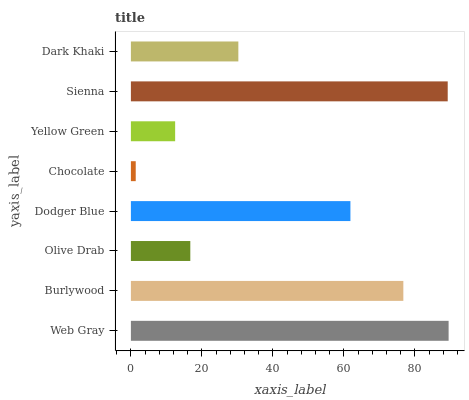Is Chocolate the minimum?
Answer yes or no. Yes. Is Web Gray the maximum?
Answer yes or no. Yes. Is Burlywood the minimum?
Answer yes or no. No. Is Burlywood the maximum?
Answer yes or no. No. Is Web Gray greater than Burlywood?
Answer yes or no. Yes. Is Burlywood less than Web Gray?
Answer yes or no. Yes. Is Burlywood greater than Web Gray?
Answer yes or no. No. Is Web Gray less than Burlywood?
Answer yes or no. No. Is Dodger Blue the high median?
Answer yes or no. Yes. Is Dark Khaki the low median?
Answer yes or no. Yes. Is Web Gray the high median?
Answer yes or no. No. Is Burlywood the low median?
Answer yes or no. No. 